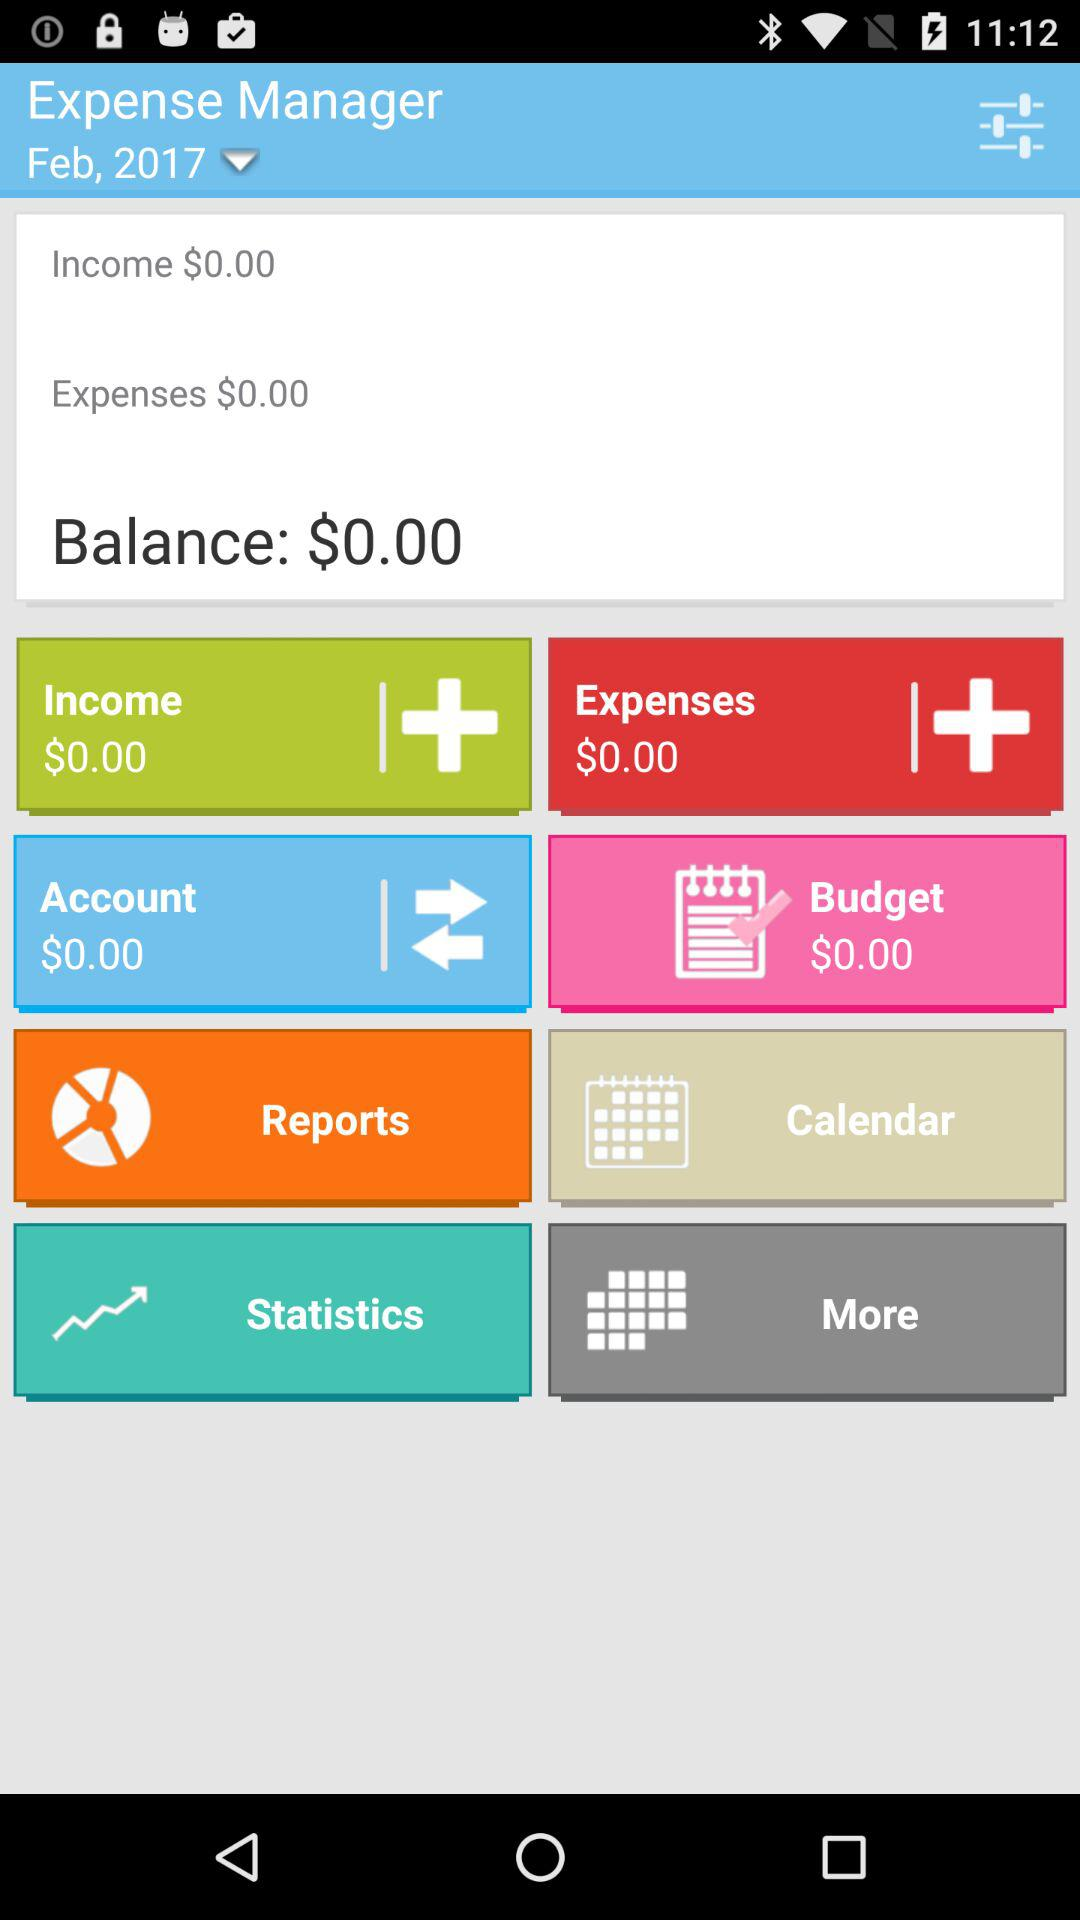How many expenses are shown there? The shown expenses are $0.00. 